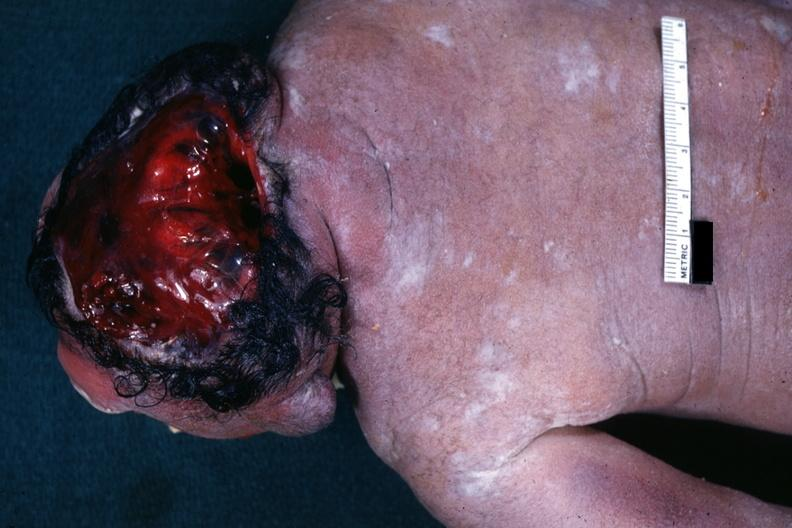s slices of liver and spleen typical tuberculous exudate is present on capsule of liver and spleen present?
Answer the question using a single word or phrase. No 